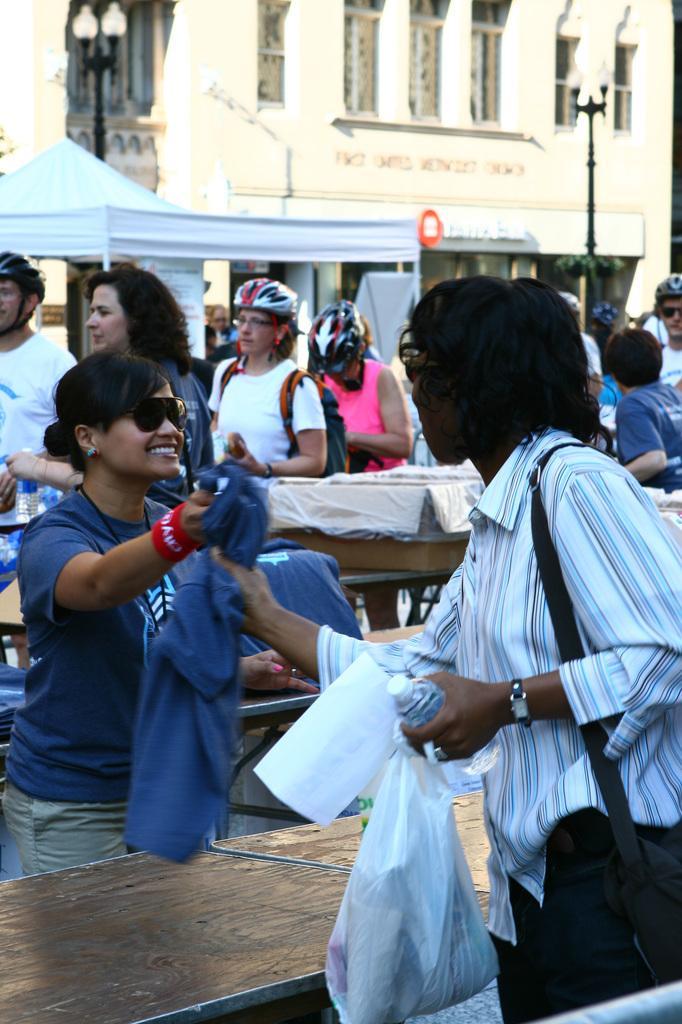Describe this image in one or two sentences. The woman on the right side is standing and she is holding a paper, plastic cover, water bottle and a blue T-shirt in her hands. In front of her, we see a table. Beside that, we see a woman on the left side is wearing a blue T-shirt and she is smiling. She is holding a blue T-shirt in her hand. Behind her, we see the carton boxes and the people are standing. There are buildings and the streetlights in the background. 